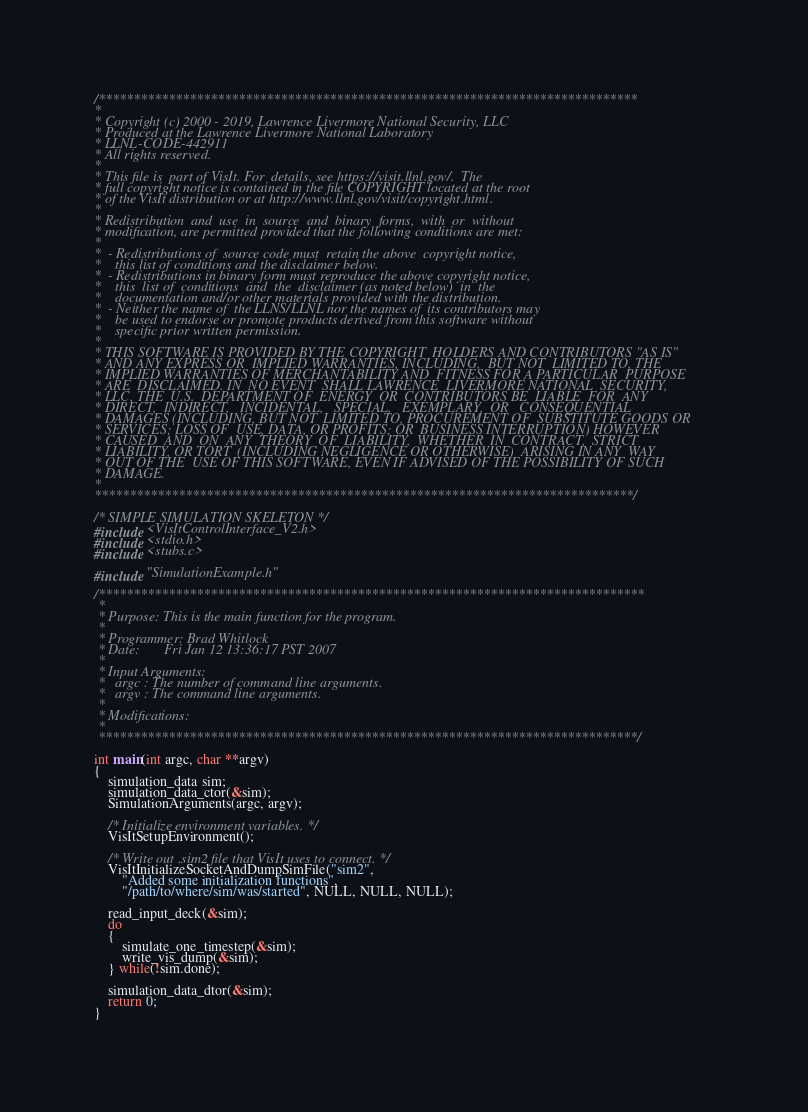<code> <loc_0><loc_0><loc_500><loc_500><_C_>/*****************************************************************************
*
* Copyright (c) 2000 - 2019, Lawrence Livermore National Security, LLC
* Produced at the Lawrence Livermore National Laboratory
* LLNL-CODE-442911
* All rights reserved.
*
* This file is  part of VisIt. For  details, see https://visit.llnl.gov/.  The
* full copyright notice is contained in the file COPYRIGHT located at the root
* of the VisIt distribution or at http://www.llnl.gov/visit/copyright.html.
*
* Redistribution  and  use  in  source  and  binary  forms,  with  or  without
* modification, are permitted provided that the following conditions are met:
*
*  - Redistributions of  source code must  retain the above  copyright notice,
*    this list of conditions and the disclaimer below.
*  - Redistributions in binary form must reproduce the above copyright notice,
*    this  list of  conditions  and  the  disclaimer (as noted below)  in  the
*    documentation and/or other materials provided with the distribution.
*  - Neither the name of  the LLNS/LLNL nor the names of  its contributors may
*    be used to endorse or promote products derived from this software without
*    specific prior written permission.
*
* THIS SOFTWARE IS PROVIDED BY THE COPYRIGHT  HOLDERS AND CONTRIBUTORS "AS IS"
* AND ANY EXPRESS OR  IMPLIED WARRANTIES, INCLUDING,  BUT NOT  LIMITED TO, THE
* IMPLIED WARRANTIES OF MERCHANTABILITY AND  FITNESS FOR A PARTICULAR  PURPOSE
* ARE  DISCLAIMED. IN  NO EVENT  SHALL LAWRENCE  LIVERMORE NATIONAL  SECURITY,
* LLC, THE  U.S.  DEPARTMENT OF  ENERGY  OR  CONTRIBUTORS BE  LIABLE  FOR  ANY
* DIRECT,  INDIRECT,   INCIDENTAL,   SPECIAL,   EXEMPLARY,  OR   CONSEQUENTIAL
* DAMAGES (INCLUDING, BUT NOT  LIMITED TO, PROCUREMENT OF  SUBSTITUTE GOODS OR
* SERVICES; LOSS OF  USE, DATA, OR PROFITS; OR  BUSINESS INTERRUPTION) HOWEVER
* CAUSED  AND  ON  ANY  THEORY  OF  LIABILITY,  WHETHER  IN  CONTRACT,  STRICT
* LIABILITY, OR TORT  (INCLUDING NEGLIGENCE OR OTHERWISE)  ARISING IN ANY  WAY
* OUT OF THE  USE OF THIS SOFTWARE, EVEN IF ADVISED OF THE POSSIBILITY OF SUCH
* DAMAGE.
*
*****************************************************************************/

/* SIMPLE SIMULATION SKELETON */
#include <VisItControlInterface_V2.h>
#include <stdio.h>
#include <stubs.c>

#include "SimulationExample.h"

/******************************************************************************
 *
 * Purpose: This is the main function for the program.
 *
 * Programmer: Brad Whitlock
 * Date:       Fri Jan 12 13:36:17 PST 2007
 *
 * Input Arguments:
 *   argc : The number of command line arguments.
 *   argv : The command line arguments.
 *
 * Modifications:
 *
 *****************************************************************************/

int main(int argc, char **argv)
{
    simulation_data sim;
    simulation_data_ctor(&sim);
    SimulationArguments(argc, argv);
   
    /* Initialize environment variables. */
    VisItSetupEnvironment();

    /* Write out .sim2 file that VisIt uses to connect. */
    VisItInitializeSocketAndDumpSimFile("sim2",
        "Added some initialization functions",
        "/path/to/where/sim/was/started", NULL, NULL, NULL);

    read_input_deck(&sim);
    do
    {
        simulate_one_timestep(&sim);
        write_vis_dump(&sim);
    } while(!sim.done);

    simulation_data_dtor(&sim);
    return 0;
}
</code> 